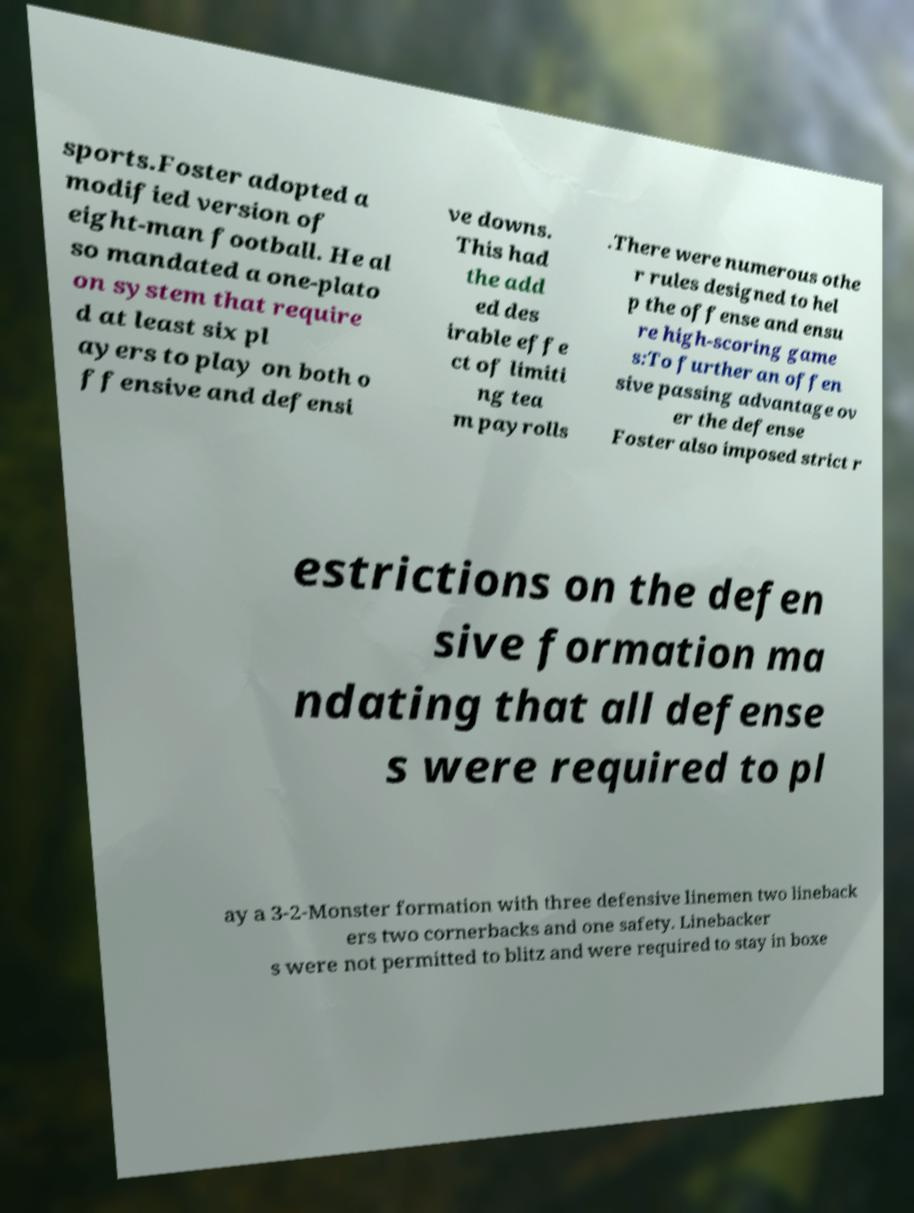Could you extract and type out the text from this image? sports.Foster adopted a modified version of eight-man football. He al so mandated a one-plato on system that require d at least six pl ayers to play on both o ffensive and defensi ve downs. This had the add ed des irable effe ct of limiti ng tea m payrolls .There were numerous othe r rules designed to hel p the offense and ensu re high-scoring game s:To further an offen sive passing advantage ov er the defense Foster also imposed strict r estrictions on the defen sive formation ma ndating that all defense s were required to pl ay a 3-2-Monster formation with three defensive linemen two lineback ers two cornerbacks and one safety. Linebacker s were not permitted to blitz and were required to stay in boxe 